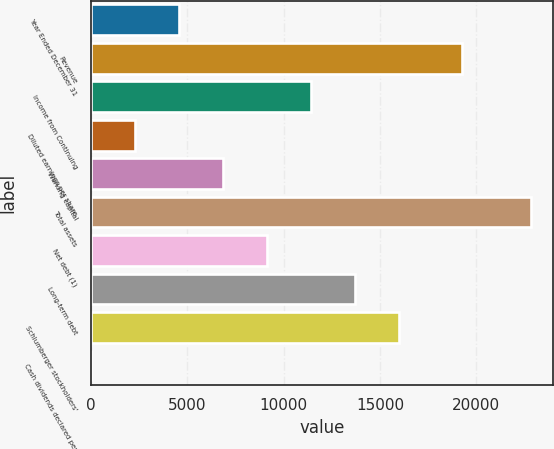<chart> <loc_0><loc_0><loc_500><loc_500><bar_chart><fcel>Year Ended December 31<fcel>Revenue<fcel>Income from Continuing<fcel>Diluted earnings per share<fcel>Working capital<fcel>Total assets<fcel>Net debt (1)<fcel>Long-term debt<fcel>Schlumberger stockholders'<fcel>Cash dividends declared per<nl><fcel>4566.8<fcel>19230<fcel>11416.2<fcel>2283.65<fcel>6849.95<fcel>22832<fcel>9133.1<fcel>13699.4<fcel>15982.5<fcel>0.5<nl></chart> 